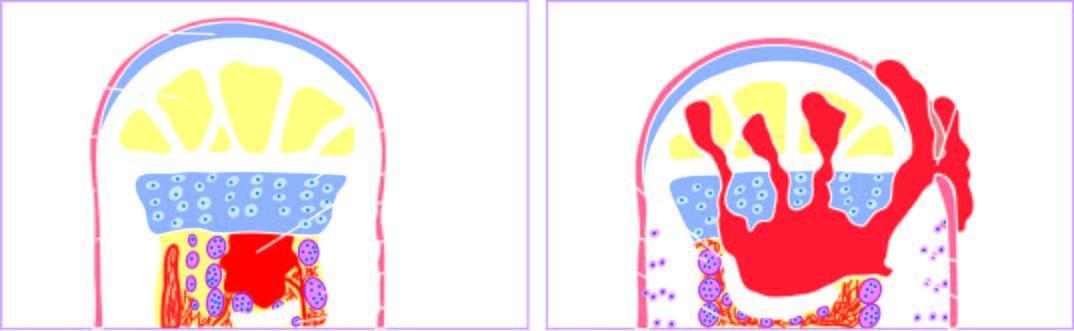does photomicrograph on right under higher magnification begin as a focus of microabscess in a vascular loop in the marrow which expands to stimulate?
Answer the question using a single word or phrase. No 